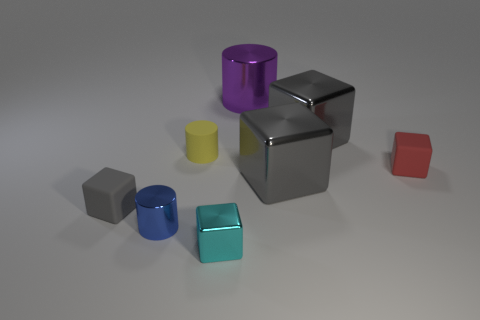Can you describe the arrangement and colors of the objects? Certainly! In the image, we observe a collection of various geometric shapes with different colors and materials. There are two cubes, one shiny and silver, the other matte and grey. A shiny purple cylinder stands out as well, alongside a smaller cyan cylinder with a metallic sheen. You can also see a reflective cyan cube, a small grey cube, and a tiny red cube. The shapes are scattered casually across a flat surface. 